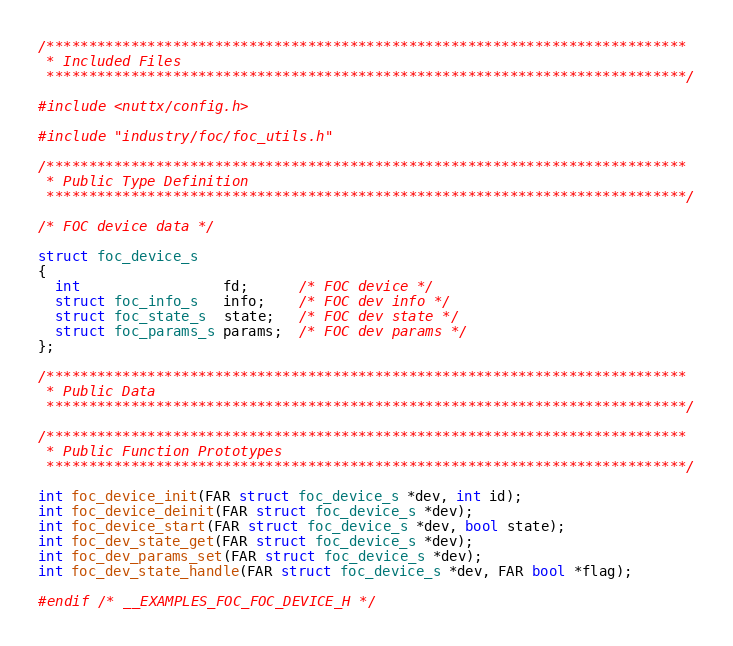<code> <loc_0><loc_0><loc_500><loc_500><_C_>/****************************************************************************
 * Included Files
 ****************************************************************************/

#include <nuttx/config.h>

#include "industry/foc/foc_utils.h"

/****************************************************************************
 * Public Type Definition
 ****************************************************************************/

/* FOC device data */

struct foc_device_s
{
  int                 fd;      /* FOC device */
  struct foc_info_s   info;    /* FOC dev info */
  struct foc_state_s  state;   /* FOC dev state */
  struct foc_params_s params;  /* FOC dev params */
};

/****************************************************************************
 * Public Data
 ****************************************************************************/

/****************************************************************************
 * Public Function Prototypes
 ****************************************************************************/

int foc_device_init(FAR struct foc_device_s *dev, int id);
int foc_device_deinit(FAR struct foc_device_s *dev);
int foc_device_start(FAR struct foc_device_s *dev, bool state);
int foc_dev_state_get(FAR struct foc_device_s *dev);
int foc_dev_params_set(FAR struct foc_device_s *dev);
int foc_dev_state_handle(FAR struct foc_device_s *dev, FAR bool *flag);

#endif /* __EXAMPLES_FOC_FOC_DEVICE_H */
</code> 